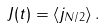Convert formula to latex. <formula><loc_0><loc_0><loc_500><loc_500>J ( t ) = \left \langle j _ { N / 2 } \right \rangle .</formula> 